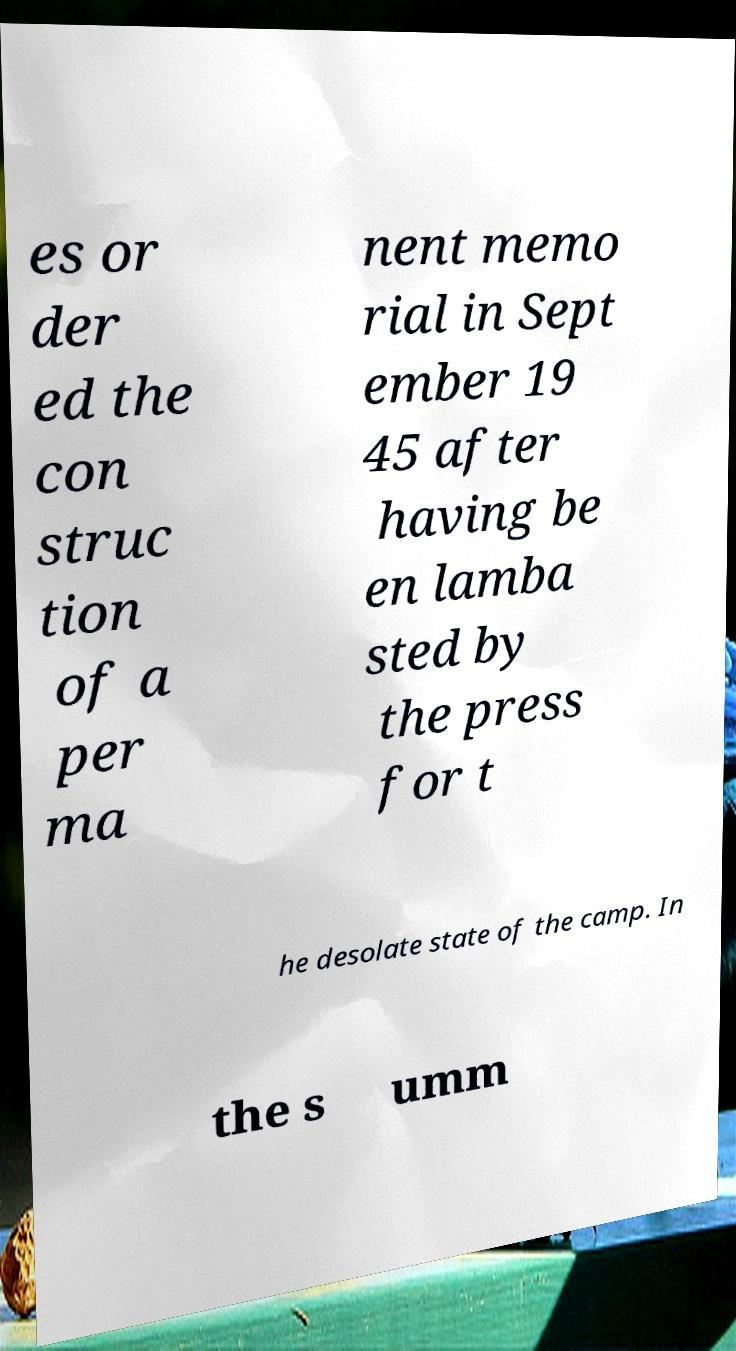Please identify and transcribe the text found in this image. es or der ed the con struc tion of a per ma nent memo rial in Sept ember 19 45 after having be en lamba sted by the press for t he desolate state of the camp. In the s umm 